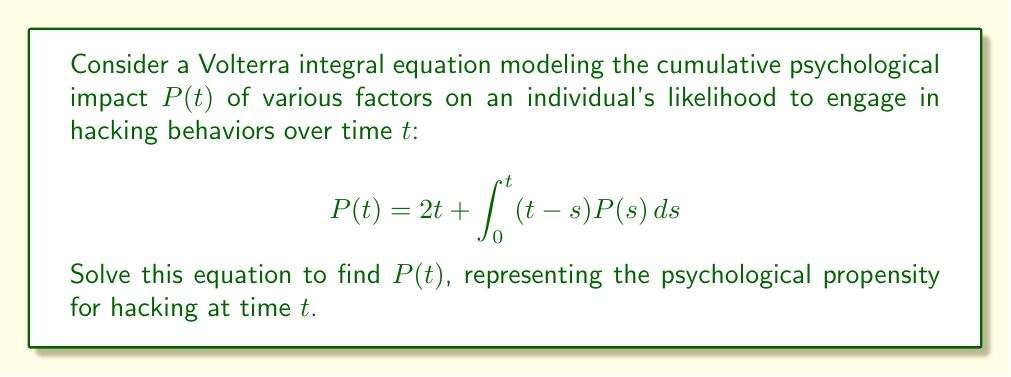Can you answer this question? To solve this Volterra integral equation, we'll use the Laplace transform method:

1) Take the Laplace transform of both sides:
   $$\mathcal{L}\{P(t)\} = \mathcal{L}\{2t\} + \mathcal{L}\{\int_0^t (t-s)P(s)ds\}$$

2) Let $\mathcal{L}\{P(t)\} = \bar{P}(s)$. Using Laplace transform properties:
   $$\bar{P}(s) = \frac{2}{s^2} + \frac{1}{s^2}\bar{P}(s)$$

3) Rearrange the equation:
   $$\bar{P}(s) - \frac{1}{s^2}\bar{P}(s) = \frac{2}{s^2}$$
   $$\bar{P}(s)(1 - \frac{1}{s^2}) = \frac{2}{s^2}$$

4) Solve for $\bar{P}(s)$:
   $$\bar{P}(s) = \frac{2}{s^2(1 - \frac{1}{s^2})} = \frac{2}{s^2 - 1}$$

5) Decompose into partial fractions:
   $$\bar{P}(s) = \frac{1}{s-1} - \frac{1}{s+1}$$

6) Take the inverse Laplace transform:
   $$P(t) = \mathcal{L}^{-1}\{\frac{1}{s-1} - \frac{1}{s+1}\} = e^t - e^{-t}$$

Therefore, the solution to the Volterra integral equation is $P(t) = e^t - e^{-t}$.
Answer: $P(t) = e^t - e^{-t}$ 